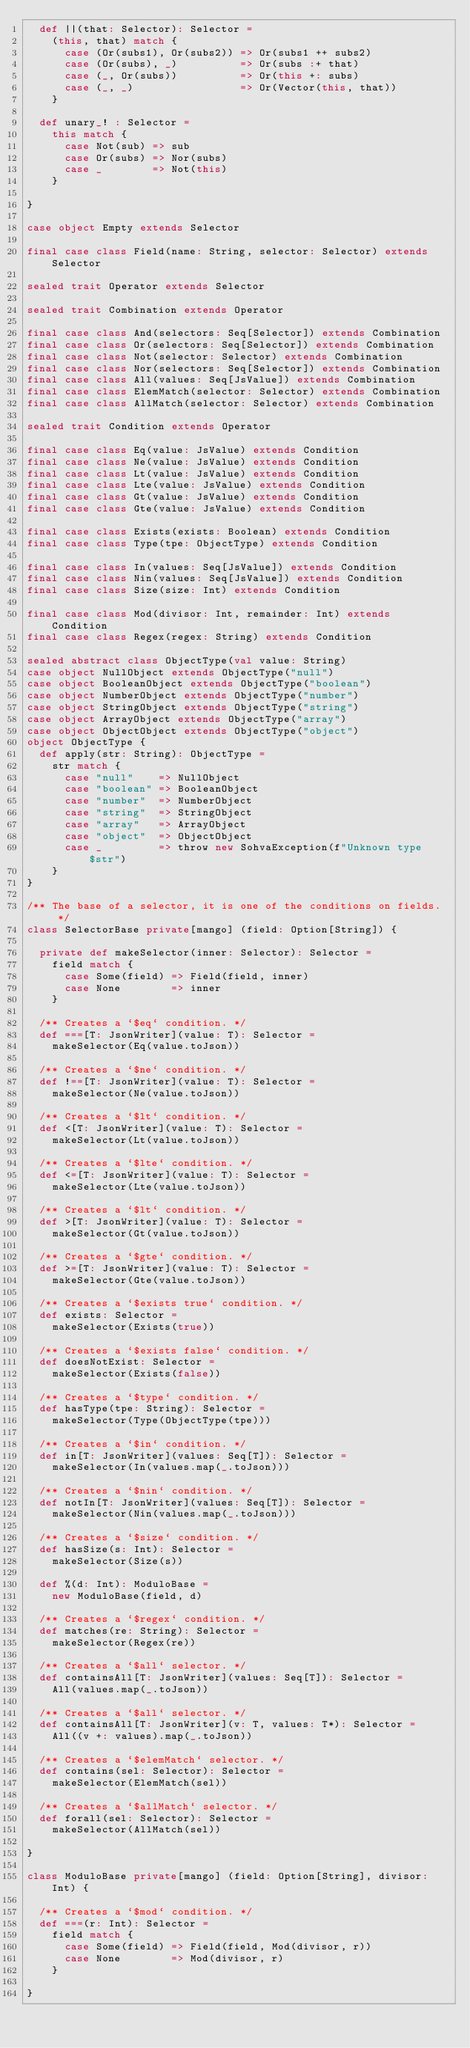Convert code to text. <code><loc_0><loc_0><loc_500><loc_500><_Scala_>  def ||(that: Selector): Selector =
    (this, that) match {
      case (Or(subs1), Or(subs2)) => Or(subs1 ++ subs2)
      case (Or(subs), _)          => Or(subs :+ that)
      case (_, Or(subs))          => Or(this +: subs)
      case (_, _)                 => Or(Vector(this, that))
    }

  def unary_! : Selector =
    this match {
      case Not(sub) => sub
      case Or(subs) => Nor(subs)
      case _        => Not(this)
    }

}

case object Empty extends Selector

final case class Field(name: String, selector: Selector) extends Selector

sealed trait Operator extends Selector

sealed trait Combination extends Operator

final case class And(selectors: Seq[Selector]) extends Combination
final case class Or(selectors: Seq[Selector]) extends Combination
final case class Not(selector: Selector) extends Combination
final case class Nor(selectors: Seq[Selector]) extends Combination
final case class All(values: Seq[JsValue]) extends Combination
final case class ElemMatch(selector: Selector) extends Combination
final case class AllMatch(selector: Selector) extends Combination

sealed trait Condition extends Operator

final case class Eq(value: JsValue) extends Condition
final case class Ne(value: JsValue) extends Condition
final case class Lt(value: JsValue) extends Condition
final case class Lte(value: JsValue) extends Condition
final case class Gt(value: JsValue) extends Condition
final case class Gte(value: JsValue) extends Condition

final case class Exists(exists: Boolean) extends Condition
final case class Type(tpe: ObjectType) extends Condition

final case class In(values: Seq[JsValue]) extends Condition
final case class Nin(values: Seq[JsValue]) extends Condition
final case class Size(size: Int) extends Condition

final case class Mod(divisor: Int, remainder: Int) extends Condition
final case class Regex(regex: String) extends Condition

sealed abstract class ObjectType(val value: String)
case object NullObject extends ObjectType("null")
case object BooleanObject extends ObjectType("boolean")
case object NumberObject extends ObjectType("number")
case object StringObject extends ObjectType("string")
case object ArrayObject extends ObjectType("array")
case object ObjectObject extends ObjectType("object")
object ObjectType {
  def apply(str: String): ObjectType =
    str match {
      case "null"    => NullObject
      case "boolean" => BooleanObject
      case "number"  => NumberObject
      case "string"  => StringObject
      case "array"   => ArrayObject
      case "object"  => ObjectObject
      case _         => throw new SohvaException(f"Unknown type $str")
    }
}

/** The base of a selector, it is one of the conditions on fields.  */
class SelectorBase private[mango] (field: Option[String]) {

  private def makeSelector(inner: Selector): Selector =
    field match {
      case Some(field) => Field(field, inner)
      case None        => inner
    }

  /** Creates a `$eq` condition. */
  def ===[T: JsonWriter](value: T): Selector =
    makeSelector(Eq(value.toJson))

  /** Creates a `$ne` condition. */
  def !==[T: JsonWriter](value: T): Selector =
    makeSelector(Ne(value.toJson))

  /** Creates a `$lt` condition. */
  def <[T: JsonWriter](value: T): Selector =
    makeSelector(Lt(value.toJson))

  /** Creates a `$lte` condition. */
  def <=[T: JsonWriter](value: T): Selector =
    makeSelector(Lte(value.toJson))

  /** Creates a `$lt` condition. */
  def >[T: JsonWriter](value: T): Selector =
    makeSelector(Gt(value.toJson))

  /** Creates a `$gte` condition. */
  def >=[T: JsonWriter](value: T): Selector =
    makeSelector(Gte(value.toJson))

  /** Creates a `$exists true` condition. */
  def exists: Selector =
    makeSelector(Exists(true))

  /** Creates a `$exists false` condition. */
  def doesNotExist: Selector =
    makeSelector(Exists(false))

  /** Creates a `$type` condition. */
  def hasType(tpe: String): Selector =
    makeSelector(Type(ObjectType(tpe)))

  /** Creates a `$in` condition. */
  def in[T: JsonWriter](values: Seq[T]): Selector =
    makeSelector(In(values.map(_.toJson)))

  /** Creates a `$nin` condition. */
  def notIn[T: JsonWriter](values: Seq[T]): Selector =
    makeSelector(Nin(values.map(_.toJson)))

  /** Creates a `$size` condition. */
  def hasSize(s: Int): Selector =
    makeSelector(Size(s))

  def %(d: Int): ModuloBase =
    new ModuloBase(field, d)

  /** Creates a `$regex` condition. */
  def matches(re: String): Selector =
    makeSelector(Regex(re))

  /** Creates a `$all` selector. */
  def containsAll[T: JsonWriter](values: Seq[T]): Selector =
    All(values.map(_.toJson))

  /** Creates a `$all` selector. */
  def containsAll[T: JsonWriter](v: T, values: T*): Selector =
    All((v +: values).map(_.toJson))

  /** Creates a `$elemMatch` selector. */
  def contains(sel: Selector): Selector =
    makeSelector(ElemMatch(sel))

  /** Creates a `$allMatch` selector. */
  def forall(sel: Selector): Selector =
    makeSelector(AllMatch(sel))

}

class ModuloBase private[mango] (field: Option[String], divisor: Int) {

  /** Creates a `$mod` condition. */
  def ===(r: Int): Selector =
    field match {
      case Some(field) => Field(field, Mod(divisor, r))
      case None        => Mod(divisor, r)
    }

}
</code> 